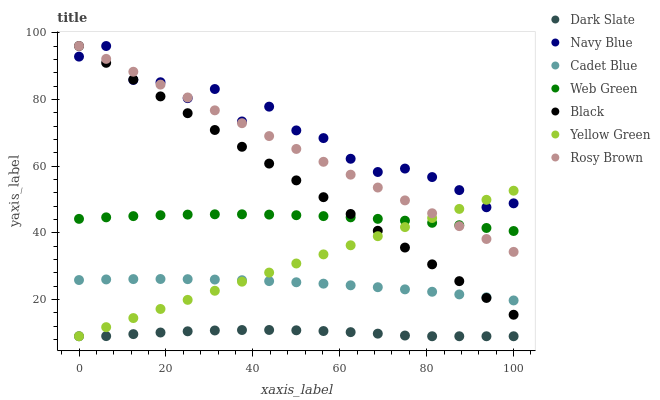Does Dark Slate have the minimum area under the curve?
Answer yes or no. Yes. Does Navy Blue have the maximum area under the curve?
Answer yes or no. Yes. Does Yellow Green have the minimum area under the curve?
Answer yes or no. No. Does Yellow Green have the maximum area under the curve?
Answer yes or no. No. Is Yellow Green the smoothest?
Answer yes or no. Yes. Is Navy Blue the roughest?
Answer yes or no. Yes. Is Navy Blue the smoothest?
Answer yes or no. No. Is Yellow Green the roughest?
Answer yes or no. No. Does Yellow Green have the lowest value?
Answer yes or no. Yes. Does Navy Blue have the lowest value?
Answer yes or no. No. Does Black have the highest value?
Answer yes or no. Yes. Does Yellow Green have the highest value?
Answer yes or no. No. Is Cadet Blue less than Navy Blue?
Answer yes or no. Yes. Is Cadet Blue greater than Dark Slate?
Answer yes or no. Yes. Does Yellow Green intersect Cadet Blue?
Answer yes or no. Yes. Is Yellow Green less than Cadet Blue?
Answer yes or no. No. Is Yellow Green greater than Cadet Blue?
Answer yes or no. No. Does Cadet Blue intersect Navy Blue?
Answer yes or no. No. 